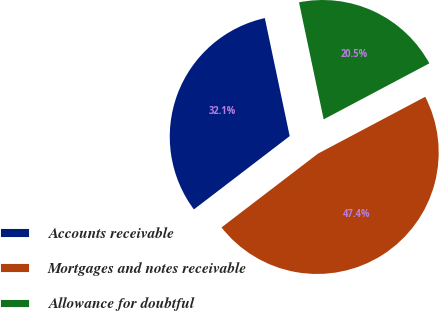Convert chart to OTSL. <chart><loc_0><loc_0><loc_500><loc_500><pie_chart><fcel>Accounts receivable<fcel>Mortgages and notes receivable<fcel>Allowance for doubtful<nl><fcel>32.09%<fcel>47.36%<fcel>20.55%<nl></chart> 